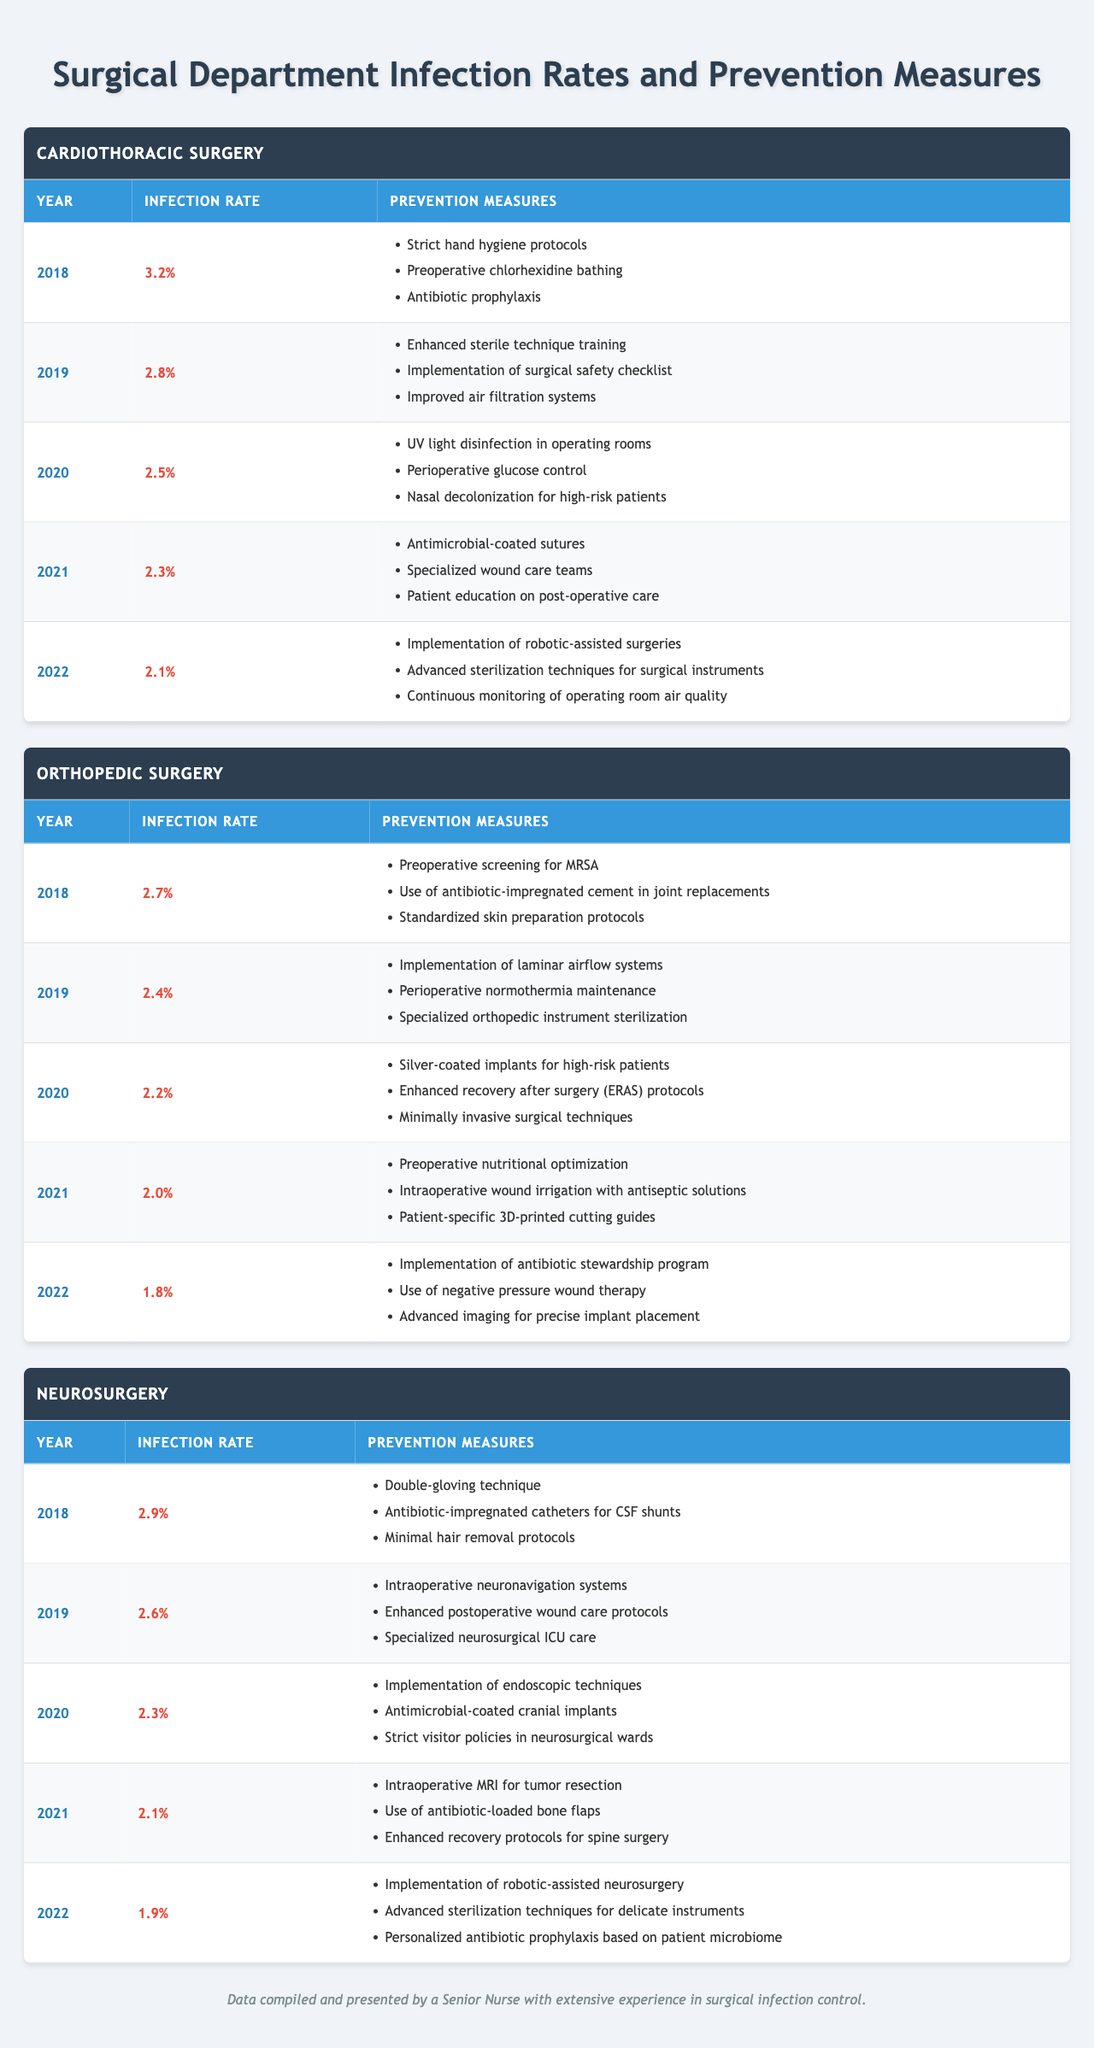What was the infection rate for Cardiothoracic Surgery in 2020? From the table, the infection rate for Cardiothoracic Surgery in 2020 is listed directly under the corresponding year. It states "2.5%".
Answer: 2.5% Which department had the highest infection rate in 2018? By analyzing the table, we can observe the infection rates for each department in 2018: Cardiothoracic Surgery is 3.2%, Orthopedic Surgery is 2.7%, and Neurosurgery is 2.9%. The highest value is 3.2%.
Answer: Cardiothoracic Surgery What are the prevention measures implemented in Orthopedic Surgery for the year 2021? Referring to the table, for the year 2021 under Orthopedic Surgery, the prevention measures listed are: "Preoperative nutritional optimization," "Intraoperative wound irrigation with antiseptic solutions," and "Patient-specific 3D-printed cutting guides."
Answer: Preoperative nutritional optimization, Intraoperative wound irrigation with antiseptic solutions, Patient-specific 3D-printed cutting guides What was the average infection rate across all departments in 2022? To calculate the average, we first identify the infection rates for 2022: Cardiothoracic Surgery is 2.1%, Orthopedic Surgery is 1.8%, and Neurosurgery is 1.9%. Adding these together gives us (2.1 + 1.8 + 1.9) = 5.8%. Then divide by 3 (the number of departments): 5.8% / 3 = 1.933% (approximately).
Answer: 1.93% Did the Neurosurgery department implement any new prevention measures between 2021 and 2022? Looking at the prevention measures for both years, the measures for 2021 include Intraoperative MRI and antibiotic-loaded bone flaps. In 2022, the measures include "Implementation of robotic-assisted neurosurgery," "Advanced sterilization techniques for delicate instruments," and "Personalized antibiotic prophylaxis based on patient microbiome." Since the 2022 measures are entirely different, there are indeed new prevention strategies.
Answer: Yes Which year saw the largest percentage decrease in infection rates for the Orthopedic Surgery department? For Orthopedic Surgery, we compare the infection rates year by year: 2018 (2.7%) to 2019 (2.4%) is a decrease of 0.3%, 2019 to 2020 (2.2%) is 0.2%, 2020 to 2021 (2.0%) is 0.2%, and 2021 to 2022 (1.8%) is 0.2%. The largest decrease is between 2018 and 2019, which is 0.3%.
Answer: 0.3% decrease from 2018 to 2019 What is the trend of infection rates in Cardiothoracic Surgery from 2018 to 2022? Reviewing the infection rates for Cardiothoracic Surgery: 2018 is 3.2%, 2019 is 2.8%, 2020 is 2.5%, 2021 is 2.3%, and 2022 is 2.1%. We can observe a consistent decline over these years, indicating an improving trend in infection rates.
Answer: A decreasing trend What was the difference in infection rates between Orthopedic Surgery and Neurosurgery in 2020? For the year 2020, Orthopedic Surgery had an infection rate of 2.2% while Neurosurgery had a rate of 2.3%. The difference would be calculated as 2.3% - 2.2% = 0.1%.
Answer: 0.1% Which prevention measure was common in both Cardiothoracic Surgery and Neurosurgery for the year 2021? In 2021, both departments listed shared prevention measures related to "specialized care" (Cardiothoracic had specialized wound care teams, and Neurosurgery had enhanced recovery protocols). However, the measures listed do not directly align as common items. Thus, no common prevention measure was stated.
Answer: No 